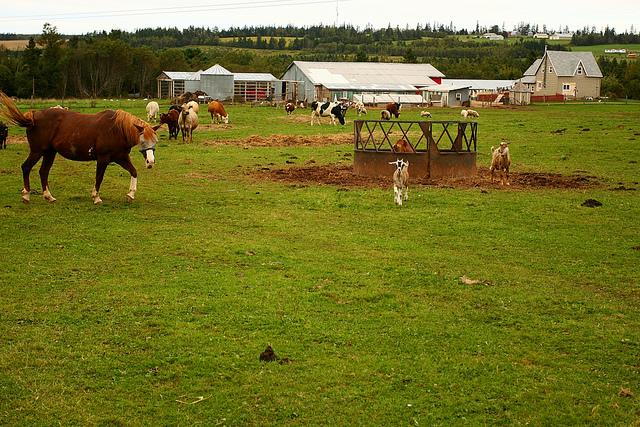How many eyes does the animal on the left have? Please explain your reasoning. two. These animals have two eyes. 